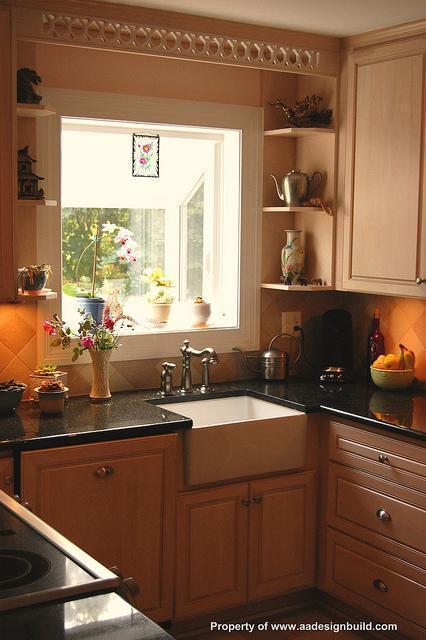What type of animals are shown on the lowest shelf to the right of the sink?
Pick the right solution, then justify: 'Answer: answer
Rationale: rationale.'
Options: Gorillas, dogs, giraffes, elephants. Answer: elephants.
Rationale: The little objects are elephants. 